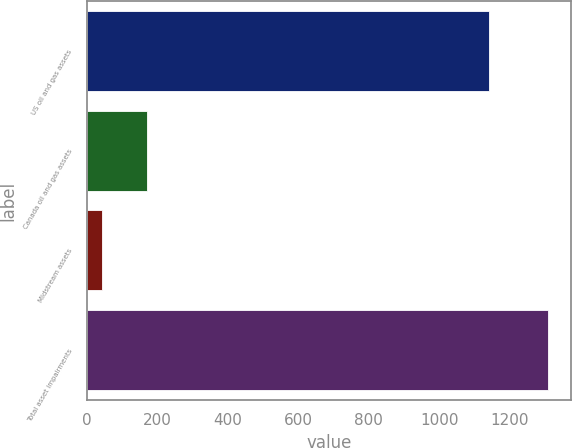Convert chart to OTSL. <chart><loc_0><loc_0><loc_500><loc_500><bar_chart><fcel>US oil and gas assets<fcel>Canada oil and gas assets<fcel>Midstream assets<fcel>Total asset impairments<nl><fcel>1142<fcel>170.4<fcel>44<fcel>1308<nl></chart> 